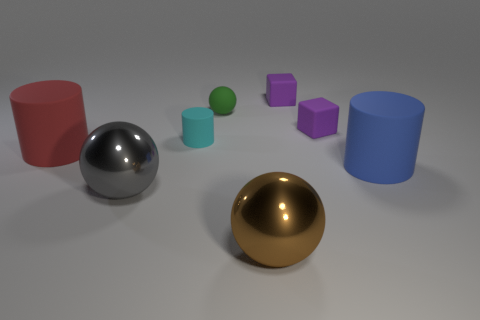What materials are the objects in the image made of? While I can't determine the exact materials from the image alone, the objects appear to represent common geometric solids with idealized surfaces. The metallic sphere, for instance, has a reflective surface resembling polished metal, while other objects have matte finishes suggestive of plastics or painted surfaces. 